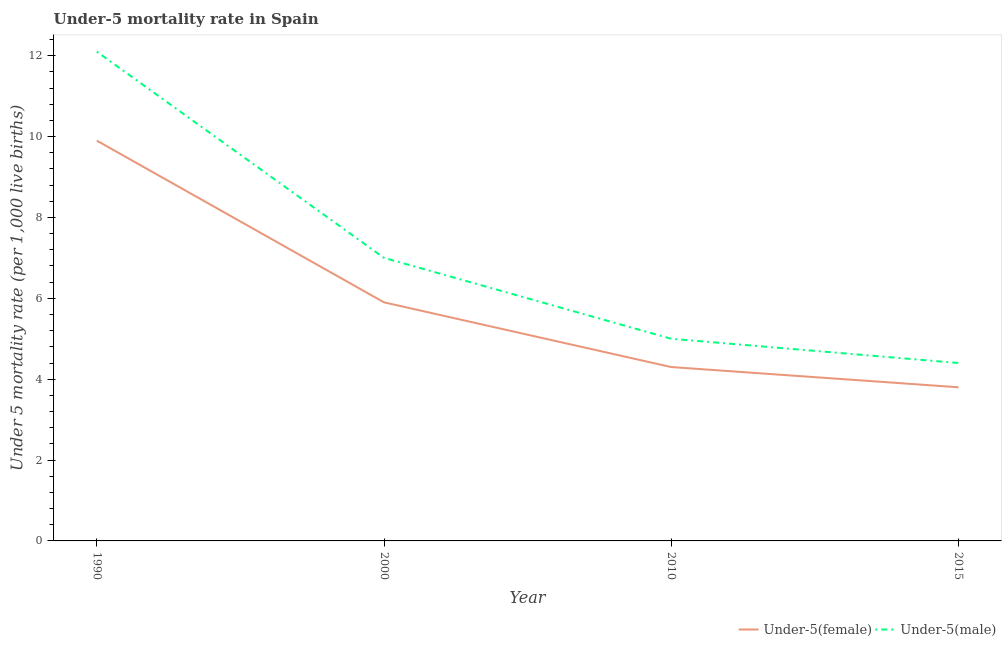Does the line corresponding to under-5 female mortality rate intersect with the line corresponding to under-5 male mortality rate?
Give a very brief answer. No. Is the number of lines equal to the number of legend labels?
Ensure brevity in your answer.  Yes. In which year was the under-5 male mortality rate maximum?
Provide a succinct answer. 1990. In which year was the under-5 female mortality rate minimum?
Provide a succinct answer. 2015. What is the total under-5 female mortality rate in the graph?
Offer a terse response. 23.9. What is the difference between the under-5 female mortality rate in 1990 and that in 2000?
Offer a terse response. 4. What is the difference between the under-5 female mortality rate in 2000 and the under-5 male mortality rate in 2010?
Give a very brief answer. 0.9. What is the average under-5 male mortality rate per year?
Your answer should be very brief. 7.12. In the year 2010, what is the difference between the under-5 female mortality rate and under-5 male mortality rate?
Offer a terse response. -0.7. In how many years, is the under-5 female mortality rate greater than 5.2?
Your answer should be compact. 2. What is the ratio of the under-5 female mortality rate in 1990 to that in 2015?
Keep it short and to the point. 2.61. Is the under-5 male mortality rate in 2000 less than that in 2010?
Provide a short and direct response. No. Is the difference between the under-5 male mortality rate in 1990 and 2000 greater than the difference between the under-5 female mortality rate in 1990 and 2000?
Provide a succinct answer. Yes. What is the difference between the highest and the second highest under-5 female mortality rate?
Make the answer very short. 4. What is the difference between the highest and the lowest under-5 male mortality rate?
Provide a succinct answer. 7.7. In how many years, is the under-5 male mortality rate greater than the average under-5 male mortality rate taken over all years?
Give a very brief answer. 1. Is the sum of the under-5 male mortality rate in 1990 and 2015 greater than the maximum under-5 female mortality rate across all years?
Your answer should be compact. Yes. Is the under-5 female mortality rate strictly less than the under-5 male mortality rate over the years?
Keep it short and to the point. Yes. How many lines are there?
Ensure brevity in your answer.  2. How many years are there in the graph?
Your answer should be very brief. 4. Are the values on the major ticks of Y-axis written in scientific E-notation?
Provide a short and direct response. No. How many legend labels are there?
Offer a terse response. 2. What is the title of the graph?
Your answer should be compact. Under-5 mortality rate in Spain. Does "Domestic liabilities" appear as one of the legend labels in the graph?
Your answer should be compact. No. What is the label or title of the X-axis?
Your answer should be very brief. Year. What is the label or title of the Y-axis?
Keep it short and to the point. Under 5 mortality rate (per 1,0 live births). What is the Under 5 mortality rate (per 1,000 live births) in Under-5(male) in 1990?
Make the answer very short. 12.1. What is the Under 5 mortality rate (per 1,000 live births) in Under-5(male) in 2015?
Offer a very short reply. 4.4. What is the total Under 5 mortality rate (per 1,000 live births) of Under-5(female) in the graph?
Ensure brevity in your answer.  23.9. What is the difference between the Under 5 mortality rate (per 1,000 live births) of Under-5(male) in 1990 and that in 2000?
Your answer should be compact. 5.1. What is the difference between the Under 5 mortality rate (per 1,000 live births) in Under-5(female) in 1990 and that in 2010?
Offer a very short reply. 5.6. What is the difference between the Under 5 mortality rate (per 1,000 live births) in Under-5(female) in 1990 and that in 2015?
Provide a short and direct response. 6.1. What is the difference between the Under 5 mortality rate (per 1,000 live births) of Under-5(male) in 1990 and that in 2015?
Make the answer very short. 7.7. What is the difference between the Under 5 mortality rate (per 1,000 live births) of Under-5(female) in 2000 and that in 2015?
Make the answer very short. 2.1. What is the difference between the Under 5 mortality rate (per 1,000 live births) of Under-5(male) in 2000 and that in 2015?
Your answer should be compact. 2.6. What is the difference between the Under 5 mortality rate (per 1,000 live births) in Under-5(female) in 2010 and that in 2015?
Offer a very short reply. 0.5. What is the difference between the Under 5 mortality rate (per 1,000 live births) of Under-5(female) in 1990 and the Under 5 mortality rate (per 1,000 live births) of Under-5(male) in 2000?
Your response must be concise. 2.9. What is the difference between the Under 5 mortality rate (per 1,000 live births) in Under-5(female) in 1990 and the Under 5 mortality rate (per 1,000 live births) in Under-5(male) in 2010?
Ensure brevity in your answer.  4.9. What is the difference between the Under 5 mortality rate (per 1,000 live births) of Under-5(female) in 1990 and the Under 5 mortality rate (per 1,000 live births) of Under-5(male) in 2015?
Your response must be concise. 5.5. What is the difference between the Under 5 mortality rate (per 1,000 live births) of Under-5(female) in 2000 and the Under 5 mortality rate (per 1,000 live births) of Under-5(male) in 2010?
Your answer should be compact. 0.9. What is the difference between the Under 5 mortality rate (per 1,000 live births) of Under-5(female) in 2000 and the Under 5 mortality rate (per 1,000 live births) of Under-5(male) in 2015?
Make the answer very short. 1.5. What is the difference between the Under 5 mortality rate (per 1,000 live births) in Under-5(female) in 2010 and the Under 5 mortality rate (per 1,000 live births) in Under-5(male) in 2015?
Provide a short and direct response. -0.1. What is the average Under 5 mortality rate (per 1,000 live births) of Under-5(female) per year?
Your response must be concise. 5.97. What is the average Under 5 mortality rate (per 1,000 live births) of Under-5(male) per year?
Your response must be concise. 7.12. In the year 1990, what is the difference between the Under 5 mortality rate (per 1,000 live births) of Under-5(female) and Under 5 mortality rate (per 1,000 live births) of Under-5(male)?
Give a very brief answer. -2.2. What is the ratio of the Under 5 mortality rate (per 1,000 live births) in Under-5(female) in 1990 to that in 2000?
Keep it short and to the point. 1.68. What is the ratio of the Under 5 mortality rate (per 1,000 live births) in Under-5(male) in 1990 to that in 2000?
Ensure brevity in your answer.  1.73. What is the ratio of the Under 5 mortality rate (per 1,000 live births) of Under-5(female) in 1990 to that in 2010?
Make the answer very short. 2.3. What is the ratio of the Under 5 mortality rate (per 1,000 live births) in Under-5(male) in 1990 to that in 2010?
Provide a short and direct response. 2.42. What is the ratio of the Under 5 mortality rate (per 1,000 live births) in Under-5(female) in 1990 to that in 2015?
Give a very brief answer. 2.61. What is the ratio of the Under 5 mortality rate (per 1,000 live births) in Under-5(male) in 1990 to that in 2015?
Offer a terse response. 2.75. What is the ratio of the Under 5 mortality rate (per 1,000 live births) of Under-5(female) in 2000 to that in 2010?
Ensure brevity in your answer.  1.37. What is the ratio of the Under 5 mortality rate (per 1,000 live births) in Under-5(male) in 2000 to that in 2010?
Give a very brief answer. 1.4. What is the ratio of the Under 5 mortality rate (per 1,000 live births) of Under-5(female) in 2000 to that in 2015?
Your answer should be very brief. 1.55. What is the ratio of the Under 5 mortality rate (per 1,000 live births) of Under-5(male) in 2000 to that in 2015?
Your answer should be very brief. 1.59. What is the ratio of the Under 5 mortality rate (per 1,000 live births) in Under-5(female) in 2010 to that in 2015?
Your answer should be very brief. 1.13. What is the ratio of the Under 5 mortality rate (per 1,000 live births) in Under-5(male) in 2010 to that in 2015?
Your response must be concise. 1.14. What is the difference between the highest and the second highest Under 5 mortality rate (per 1,000 live births) of Under-5(female)?
Your answer should be compact. 4. What is the difference between the highest and the lowest Under 5 mortality rate (per 1,000 live births) in Under-5(female)?
Provide a short and direct response. 6.1. 